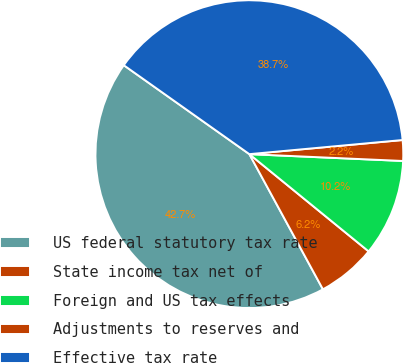Convert chart to OTSL. <chart><loc_0><loc_0><loc_500><loc_500><pie_chart><fcel>US federal statutory tax rate<fcel>State income tax net of<fcel>Foreign and US tax effects<fcel>Adjustments to reserves and<fcel>Effective tax rate<nl><fcel>42.74%<fcel>6.18%<fcel>10.18%<fcel>2.17%<fcel>38.73%<nl></chart> 